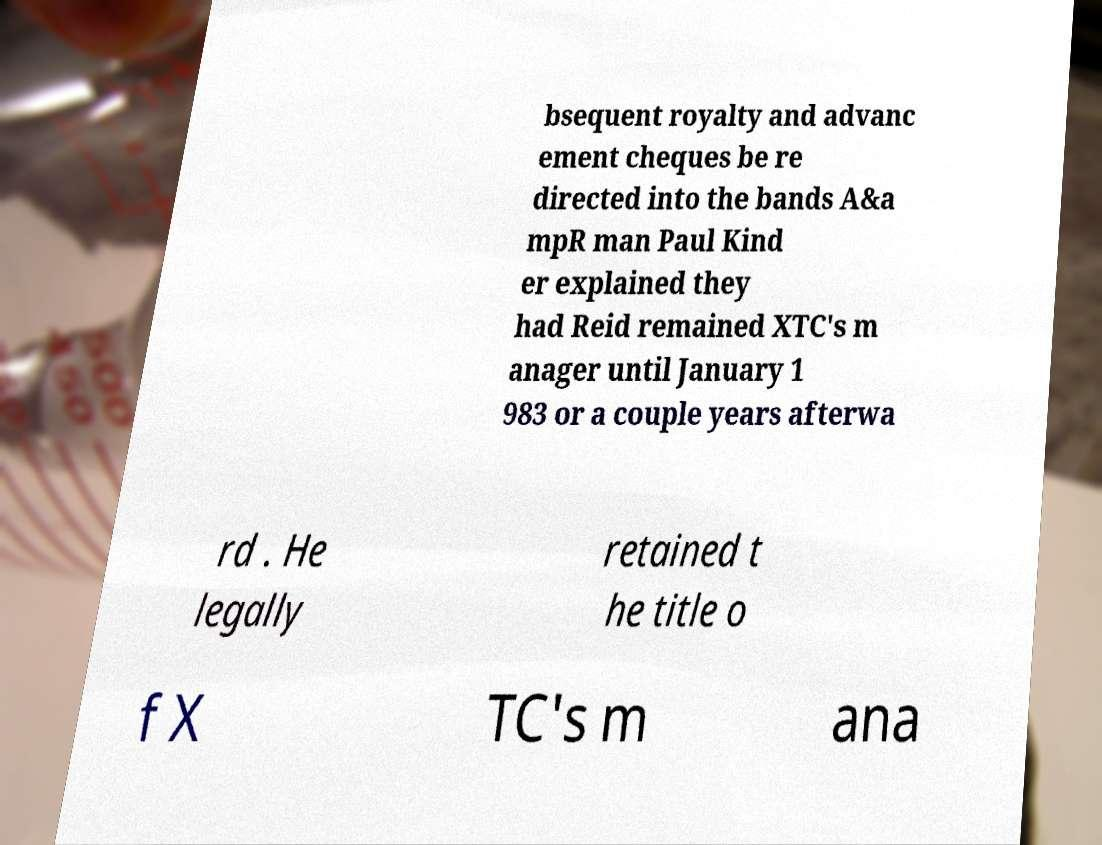What messages or text are displayed in this image? I need them in a readable, typed format. bsequent royalty and advanc ement cheques be re directed into the bands A&a mpR man Paul Kind er explained they had Reid remained XTC's m anager until January 1 983 or a couple years afterwa rd . He legally retained t he title o f X TC's m ana 